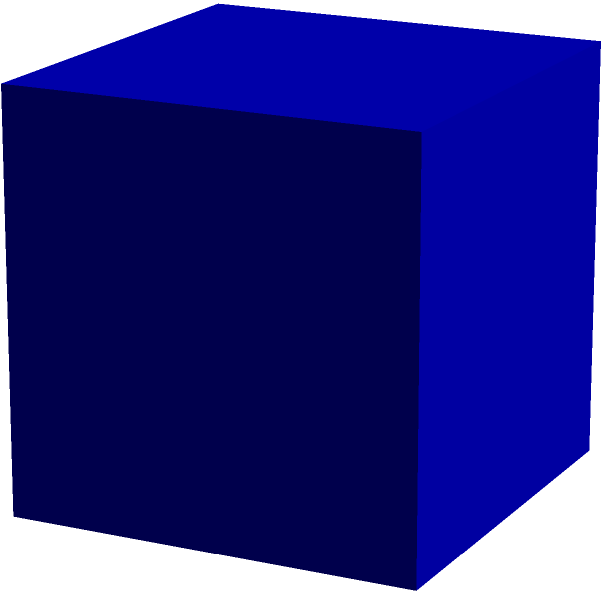As a social media manager, you're creating content for a new eco-friendly packaging campaign. The brand is launching a cube-shaped product box with sides measuring 5 cm. To highlight the reduced material usage, you need to calculate the total surface area of the packaging for a promotional post. What is the total surface area of this cube-shaped product packaging? To calculate the total surface area of a cube, we need to follow these steps:

1. Identify the length of one side of the cube:
   Side length = 5 cm

2. Calculate the area of one face of the cube:
   Area of one face = side length × side length
   $A = 5 \text{ cm} \times 5 \text{ cm} = 25 \text{ cm}^2$

3. Determine the number of faces on a cube:
   A cube has 6 faces

4. Calculate the total surface area by multiplying the area of one face by the number of faces:
   Total surface area = area of one face × number of faces
   $SA = 25 \text{ cm}^2 \times 6 = 150 \text{ cm}^2$

Therefore, the total surface area of the cube-shaped product packaging is 150 square centimeters.
Answer: $150 \text{ cm}^2$ 